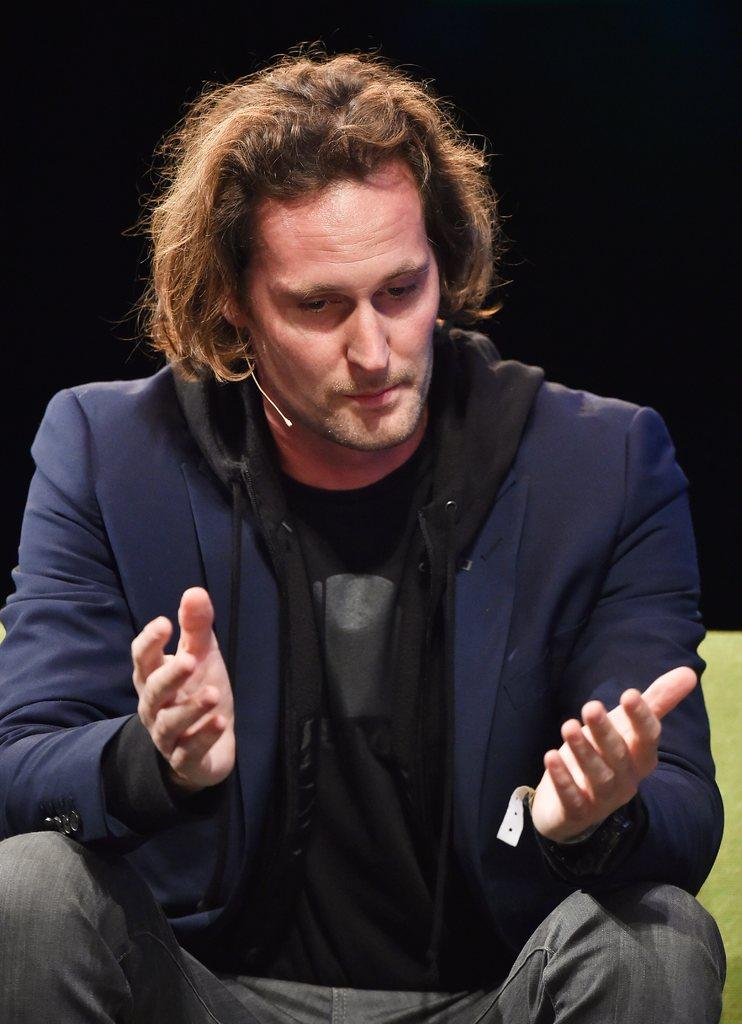Who is present in the image? There is a man in the image. What is the man doing in the image? The man is sitting on a chair. What can be observed about the background of the image? The background of the image is dark. What type of crack can be seen on the man's face in the image? There is no crack visible on the man's face in the image. What word is the man saying in the image? The image does not provide any information about the man's speech or words. 